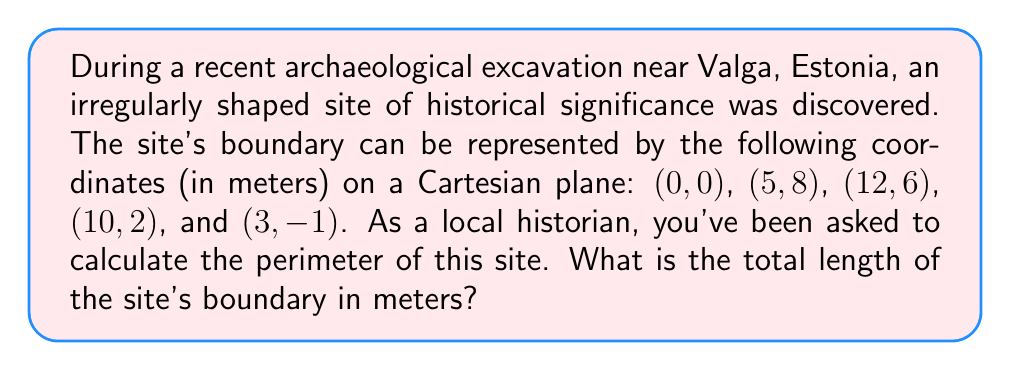Could you help me with this problem? To find the perimeter of the irregularly shaped archaeological site, we need to calculate the distances between consecutive points and sum them up. We'll use the distance formula between two points $(x_1, y_1)$ and $(x_2, y_2)$:

$$d = \sqrt{(x_2 - x_1)^2 + (y_2 - y_1)^2}$$

Let's calculate the distance for each side:

1. From (0, 0) to (5, 8):
   $$d_1 = \sqrt{(5 - 0)^2 + (8 - 0)^2} = \sqrt{25 + 64} = \sqrt{89} \approx 9.43 \text{ m}$$

2. From (5, 8) to (12, 6):
   $$d_2 = \sqrt{(12 - 5)^2 + (6 - 8)^2} = \sqrt{49 + 4} = \sqrt{53} \approx 7.28 \text{ m}$$

3. From (12, 6) to (10, 2):
   $$d_3 = \sqrt{(10 - 12)^2 + (2 - 6)^2} = \sqrt{4 + 16} = \sqrt{20} \approx 4.47 \text{ m}$$

4. From (10, 2) to (3, -1):
   $$d_4 = \sqrt{(3 - 10)^2 + (-1 - 2)^2} = \sqrt{49 + 9} = \sqrt{58} \approx 7.62 \text{ m}$$

5. From (3, -1) back to (0, 0):
   $$d_5 = \sqrt{(0 - 3)^2 + (0 - (-1))^2} = \sqrt{9 + 1} = \sqrt{10} \approx 3.16 \text{ m}$$

Now, we sum up all these distances to get the total perimeter:

$$\text{Perimeter} = d_1 + d_2 + d_3 + d_4 + d_5$$
$$\text{Perimeter} \approx 9.43 + 7.28 + 4.47 + 7.62 + 3.16 = 31.96 \text{ m}$$

Therefore, the perimeter of the archaeological site is approximately 31.96 meters.
Answer: 31.96 m 